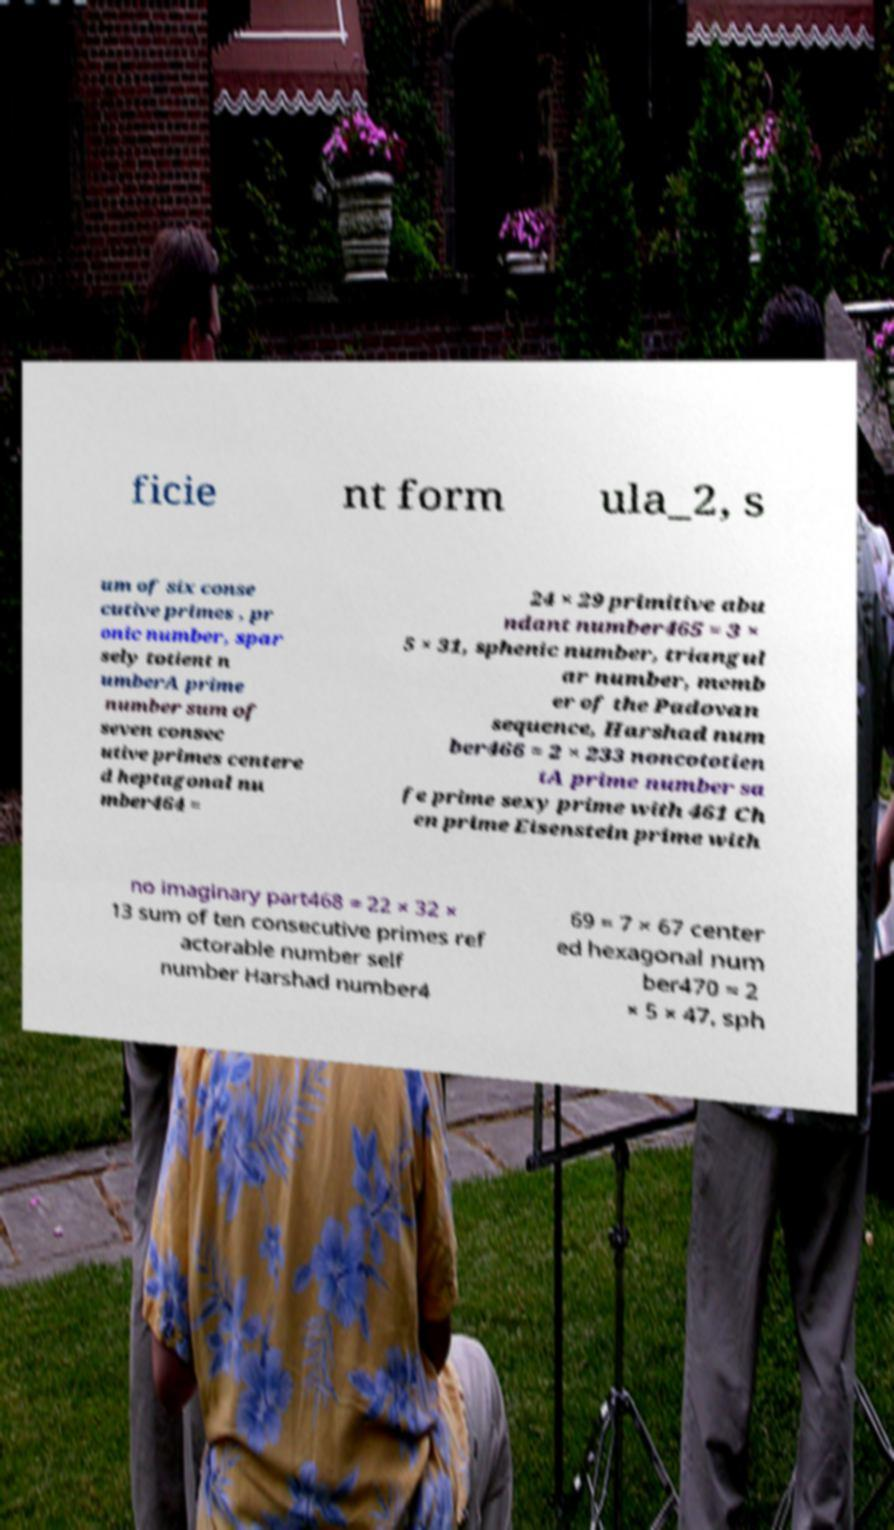Please read and relay the text visible in this image. What does it say? ficie nt form ula_2, s um of six conse cutive primes , pr onic number, spar sely totient n umberA prime number sum of seven consec utive primes centere d heptagonal nu mber464 = 24 × 29 primitive abu ndant number465 = 3 × 5 × 31, sphenic number, triangul ar number, memb er of the Padovan sequence, Harshad num ber466 = 2 × 233 noncototien tA prime number sa fe prime sexy prime with 461 Ch en prime Eisenstein prime with no imaginary part468 = 22 × 32 × 13 sum of ten consecutive primes ref actorable number self number Harshad number4 69 = 7 × 67 center ed hexagonal num ber470 = 2 × 5 × 47, sph 